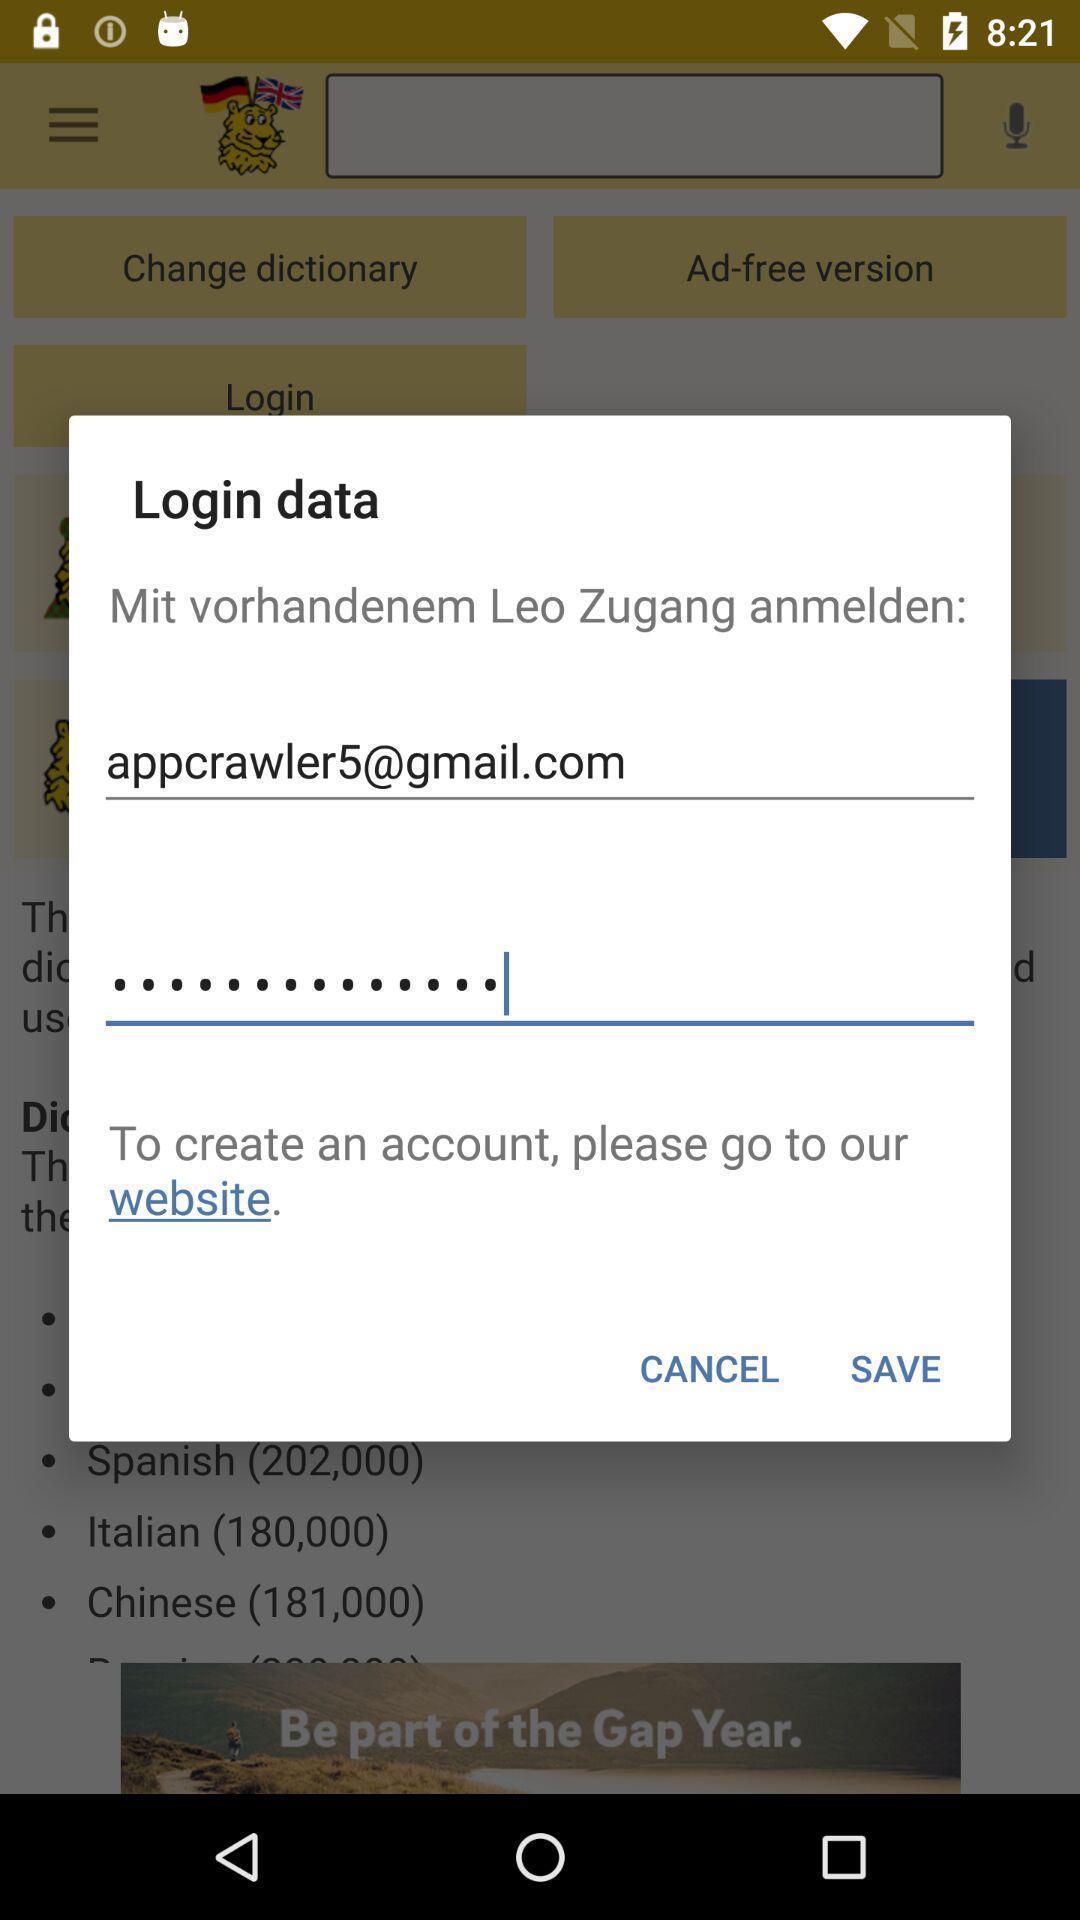Describe the key features of this screenshot. Pop-up showing login data. 